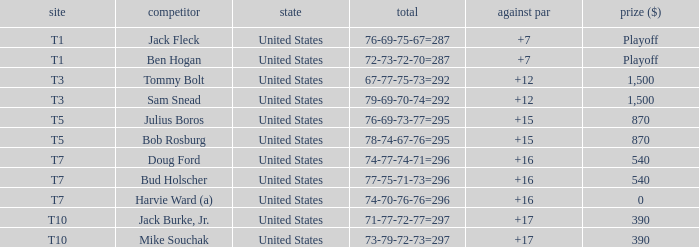Which money has player Jack Fleck with t1 place? Playoff. 